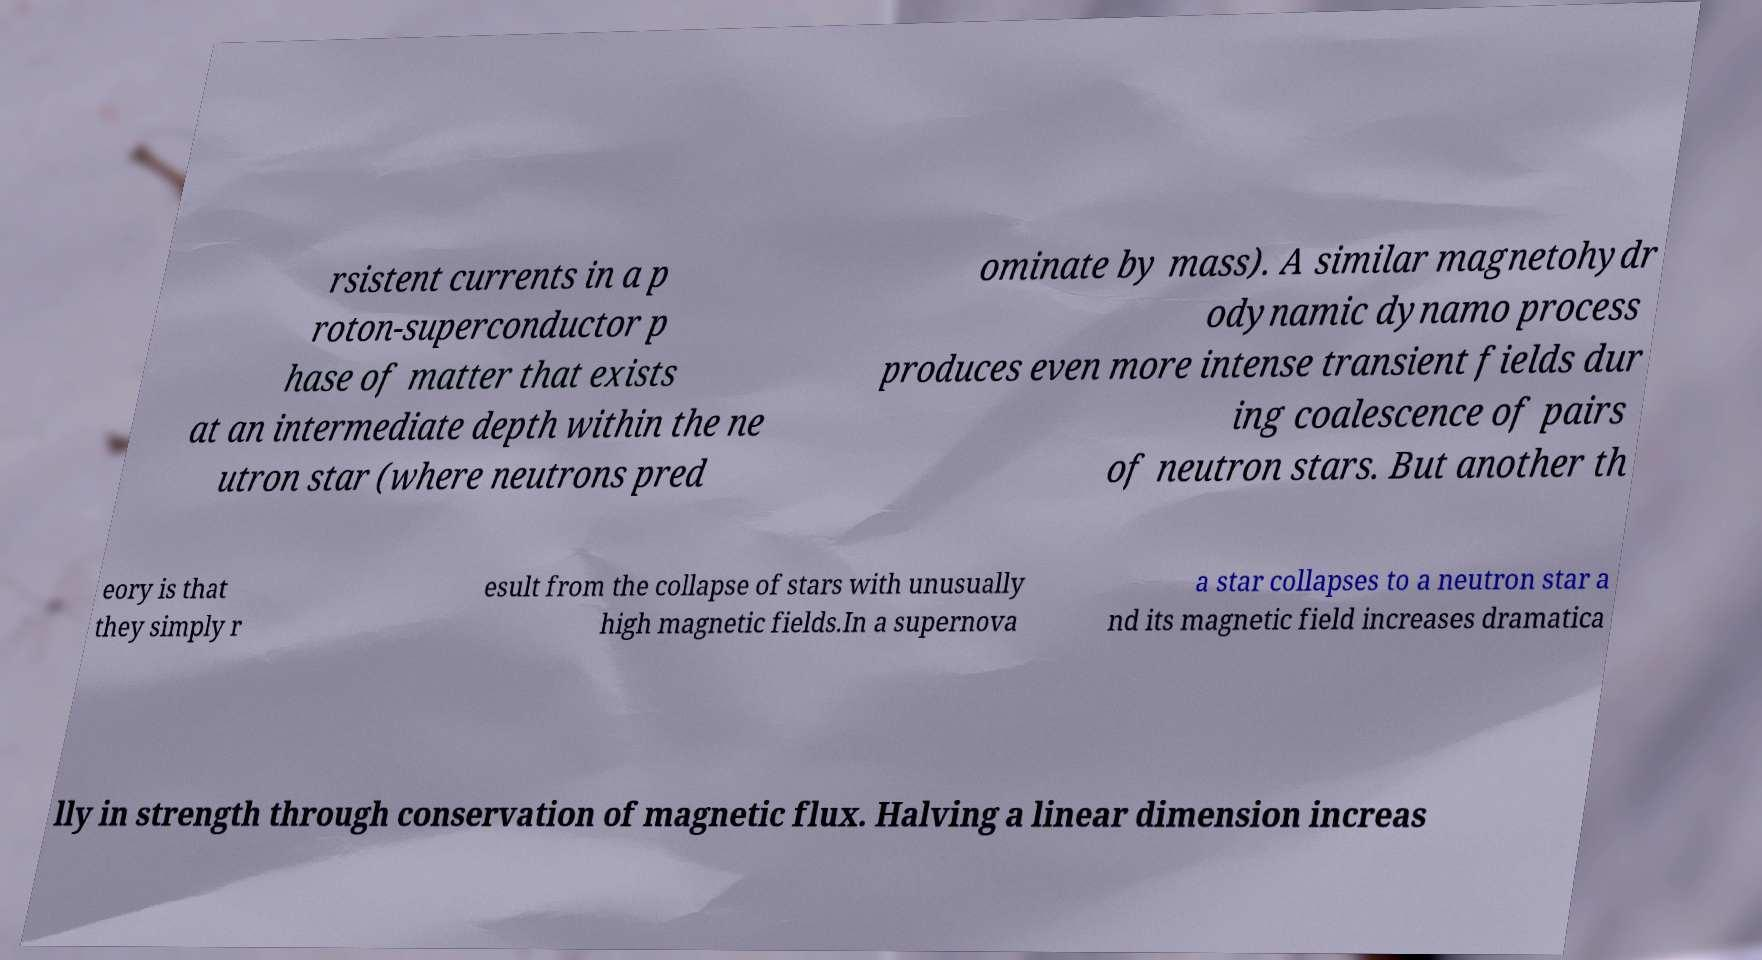Please identify and transcribe the text found in this image. rsistent currents in a p roton-superconductor p hase of matter that exists at an intermediate depth within the ne utron star (where neutrons pred ominate by mass). A similar magnetohydr odynamic dynamo process produces even more intense transient fields dur ing coalescence of pairs of neutron stars. But another th eory is that they simply r esult from the collapse of stars with unusually high magnetic fields.In a supernova a star collapses to a neutron star a nd its magnetic field increases dramatica lly in strength through conservation of magnetic flux. Halving a linear dimension increas 